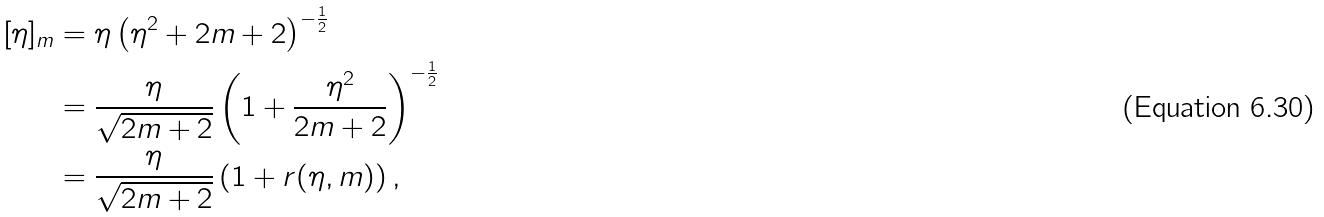<formula> <loc_0><loc_0><loc_500><loc_500>[ \eta ] _ { m } & = \eta \left ( \eta ^ { 2 } + 2 m + 2 \right ) ^ { - \frac { 1 } { 2 } } \\ & = \frac { \eta } { \sqrt { 2 m + 2 } } \left ( 1 + \frac { \eta ^ { 2 } } { 2 m + 2 } \right ) ^ { - \frac { 1 } { 2 } } \\ & = \frac { \eta } { \sqrt { 2 m + 2 } } \left ( 1 + r ( \eta , m ) \right ) ,</formula> 